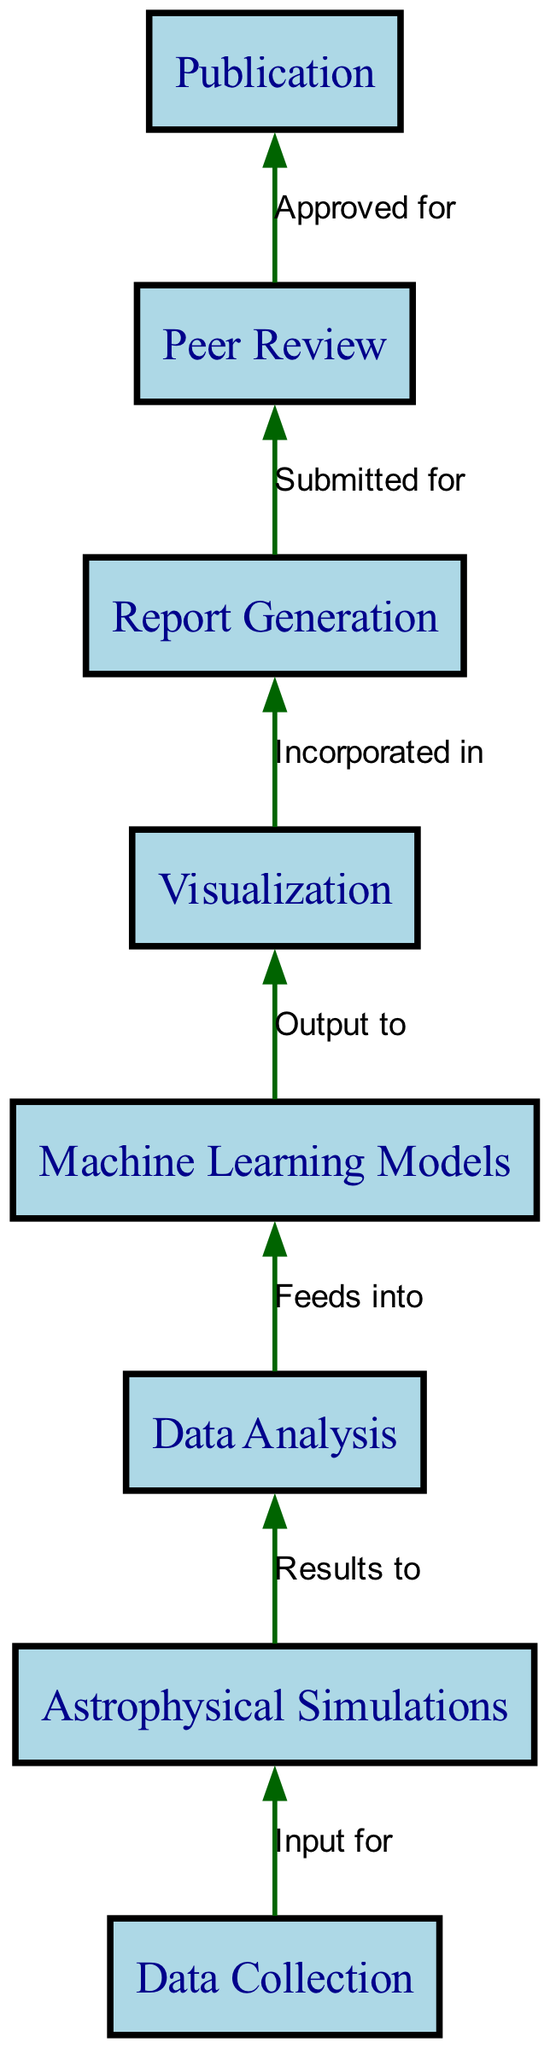What is the first action in the workflow? The diagram shows "Data Collection" as the first node, indicating it is the initial action in the collaborative workflow for the research project.
Answer: Data Collection How many nodes are present in the diagram? By counting the unique nodes listed in the data section, there are eight nodes representing different stages in the workflow.
Answer: Eight What does "Data Analysis" feed into? The diagram indicates that "Data Analysis" (Node 3) is connected to "Machine Learning Models" (Node 4) as the next step in the workflow. This means the output of data analysis is used in the machine learning phase.
Answer: Machine Learning Models In what stage is the report incorporated? According to the diagram, "Visualization" (Node 5) is incorporated in "Report Generation" (Node 6). This indicates that the visual data outputs contribute to the content of the reports.
Answer: Report Generation What is the last step before publication? The diagram shows that "Peer Review" (Node 7) is the last step before reaching "Publication" (Node 8), indicating reviews must happen before the publication process.
Answer: Peer Review What relationship exists between "Astrophysical Simulations" and "Data Collection"? The diagram specifies that "Data Collection" (Node 1) serves as input for "Astrophysical Simulations" (Node 2), indicating that data collection is necessary for running simulations.
Answer: Input for Which node directly outputs to "Visualization"? The flow chart indicates that "Machine Learning Models" (Node 4) directly outputs to "Visualization" (Node 5), meaning the results from machine learning are visually represented next.
Answer: Visualization What action follows the approval in the publication process? The last action in the flow chart is "Publication" (Node 8), which follows after the peer review has been approved, signifying the final outcome of the research project.
Answer: Publication 